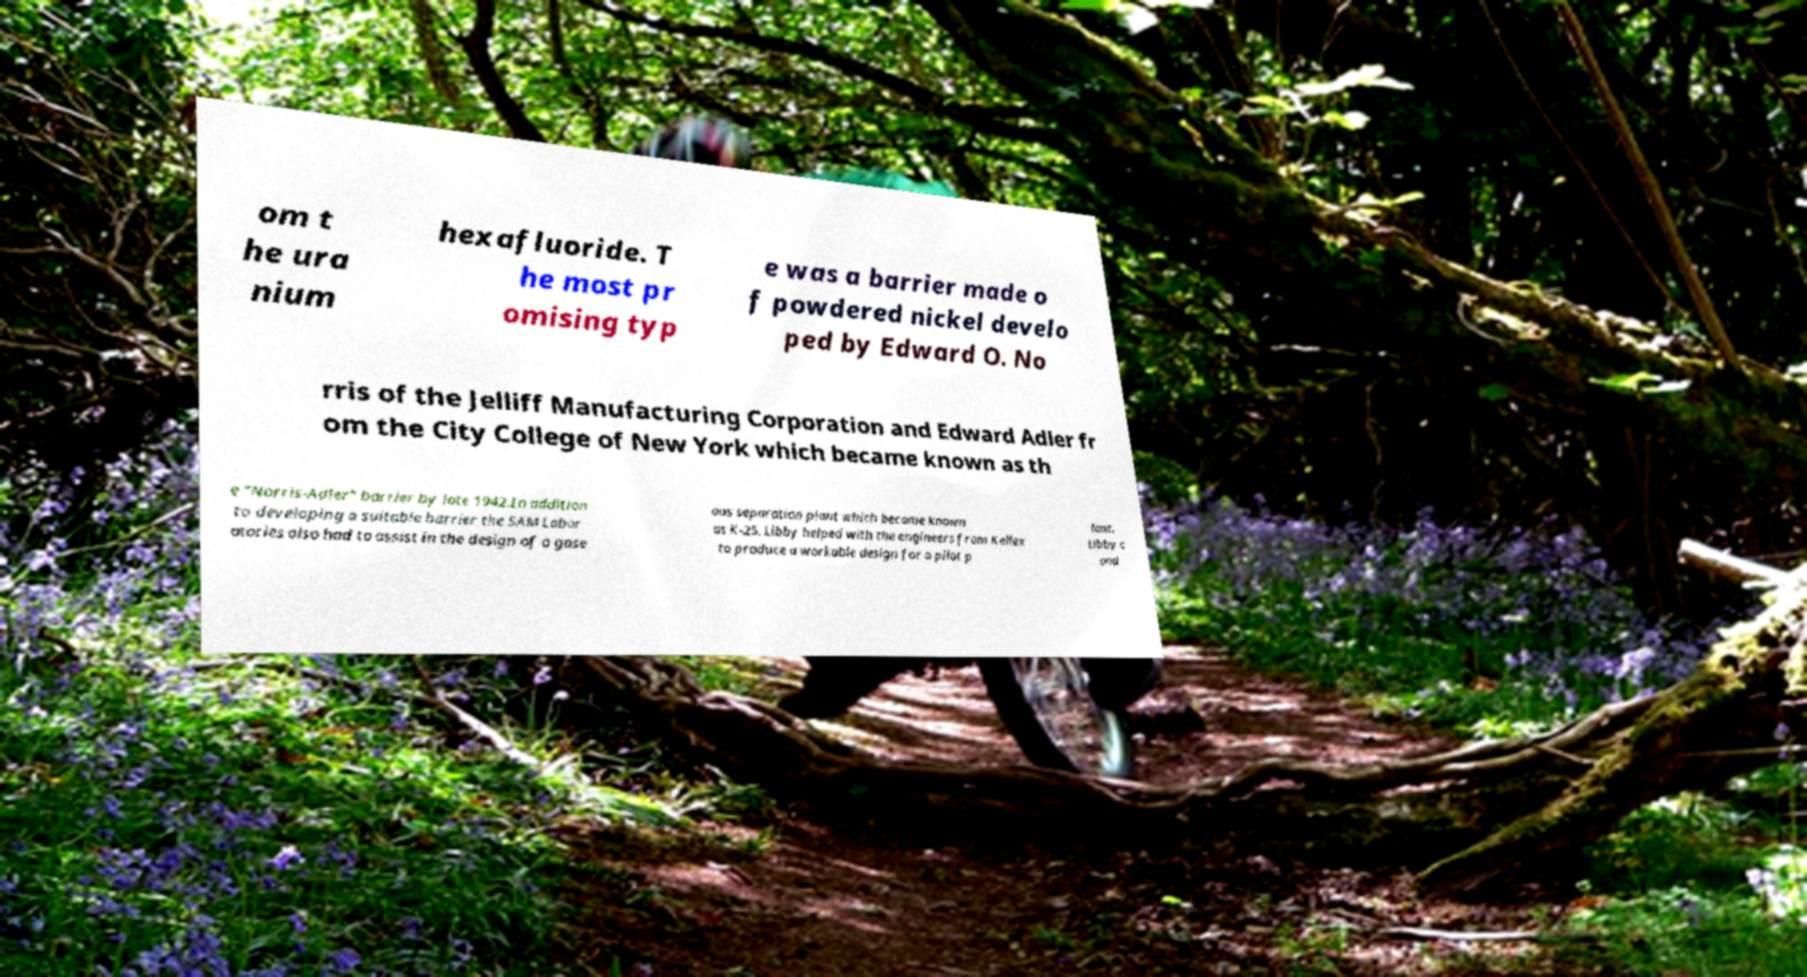Could you extract and type out the text from this image? om t he ura nium hexafluoride. T he most pr omising typ e was a barrier made o f powdered nickel develo ped by Edward O. No rris of the Jelliff Manufacturing Corporation and Edward Adler fr om the City College of New York which became known as th e "Norris-Adler" barrier by late 1942.In addition to developing a suitable barrier the SAM Labor atories also had to assist in the design of a gase ous separation plant which became known as K-25. Libby helped with the engineers from Kellex to produce a workable design for a pilot p lant. Libby c ond 